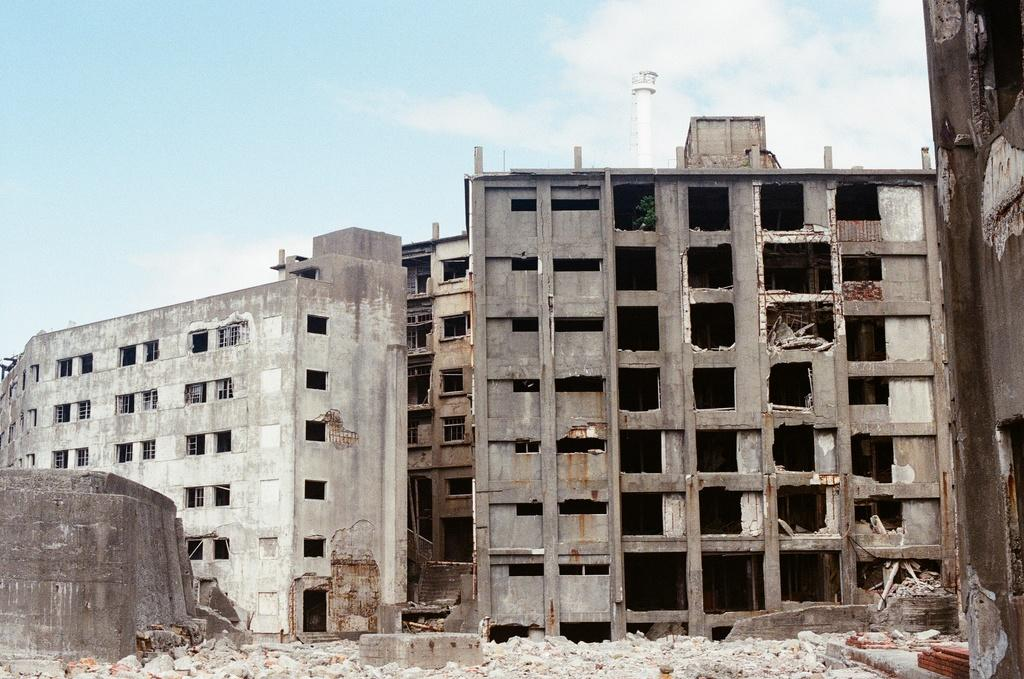What type of structures are present in the image? There are buildings in the image. What colors can be seen on the buildings? The buildings have cream, grey, and brown colors. What can be found on the ground in the image? There are rocks on the ground in the image. What is visible in the background of the image? The sky is visible in the background of the image, and there is a white-colored tower. What type of art can be seen on the feet of the people in the image? There are no people or feet present in the image; it features buildings, rocks, and a white-colored tower. 